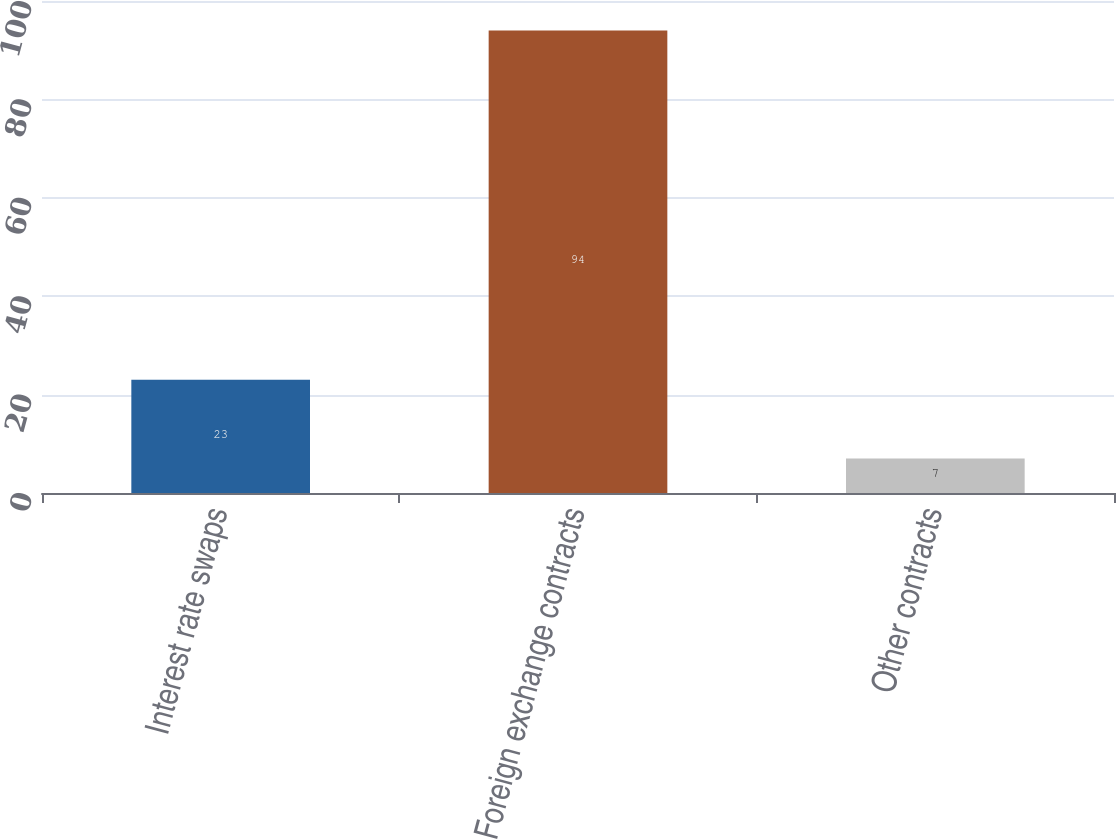<chart> <loc_0><loc_0><loc_500><loc_500><bar_chart><fcel>Interest rate swaps<fcel>Foreign exchange contracts<fcel>Other contracts<nl><fcel>23<fcel>94<fcel>7<nl></chart> 